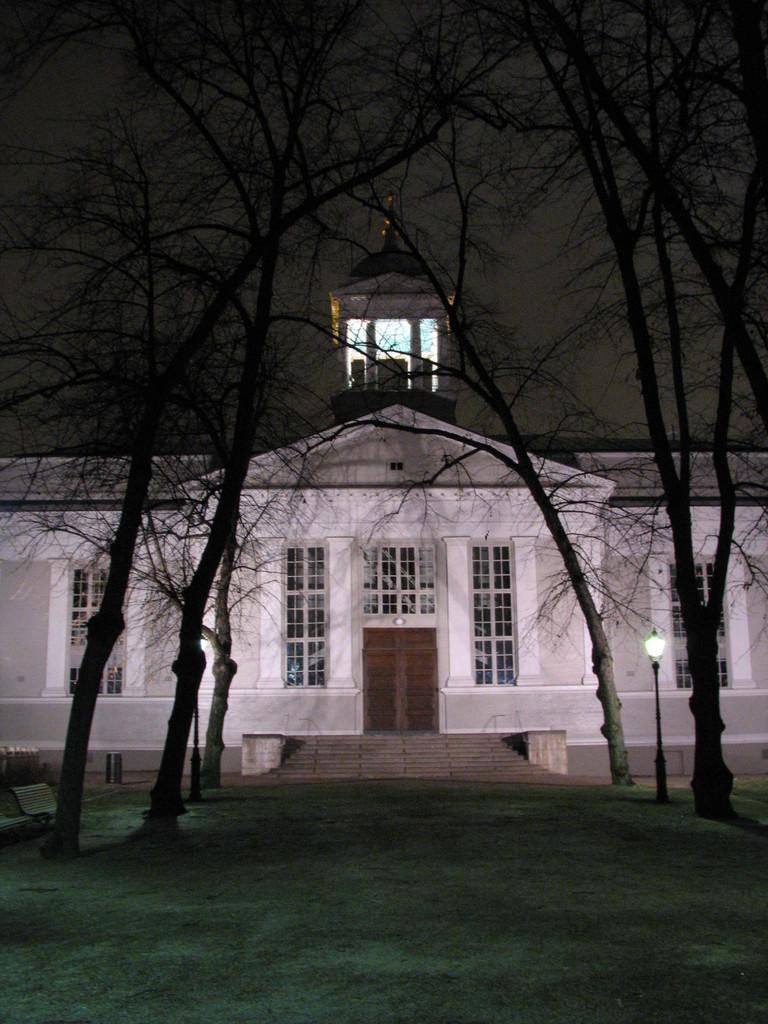What type of structure is visible in the image? There is a building in the image. What can be seen in front of the building? There are trees and benches in front of the building. What type of fruit is being used to play chess on the hospital bed in the image? There is no fruit, chess game, or hospital bed present in the image. 